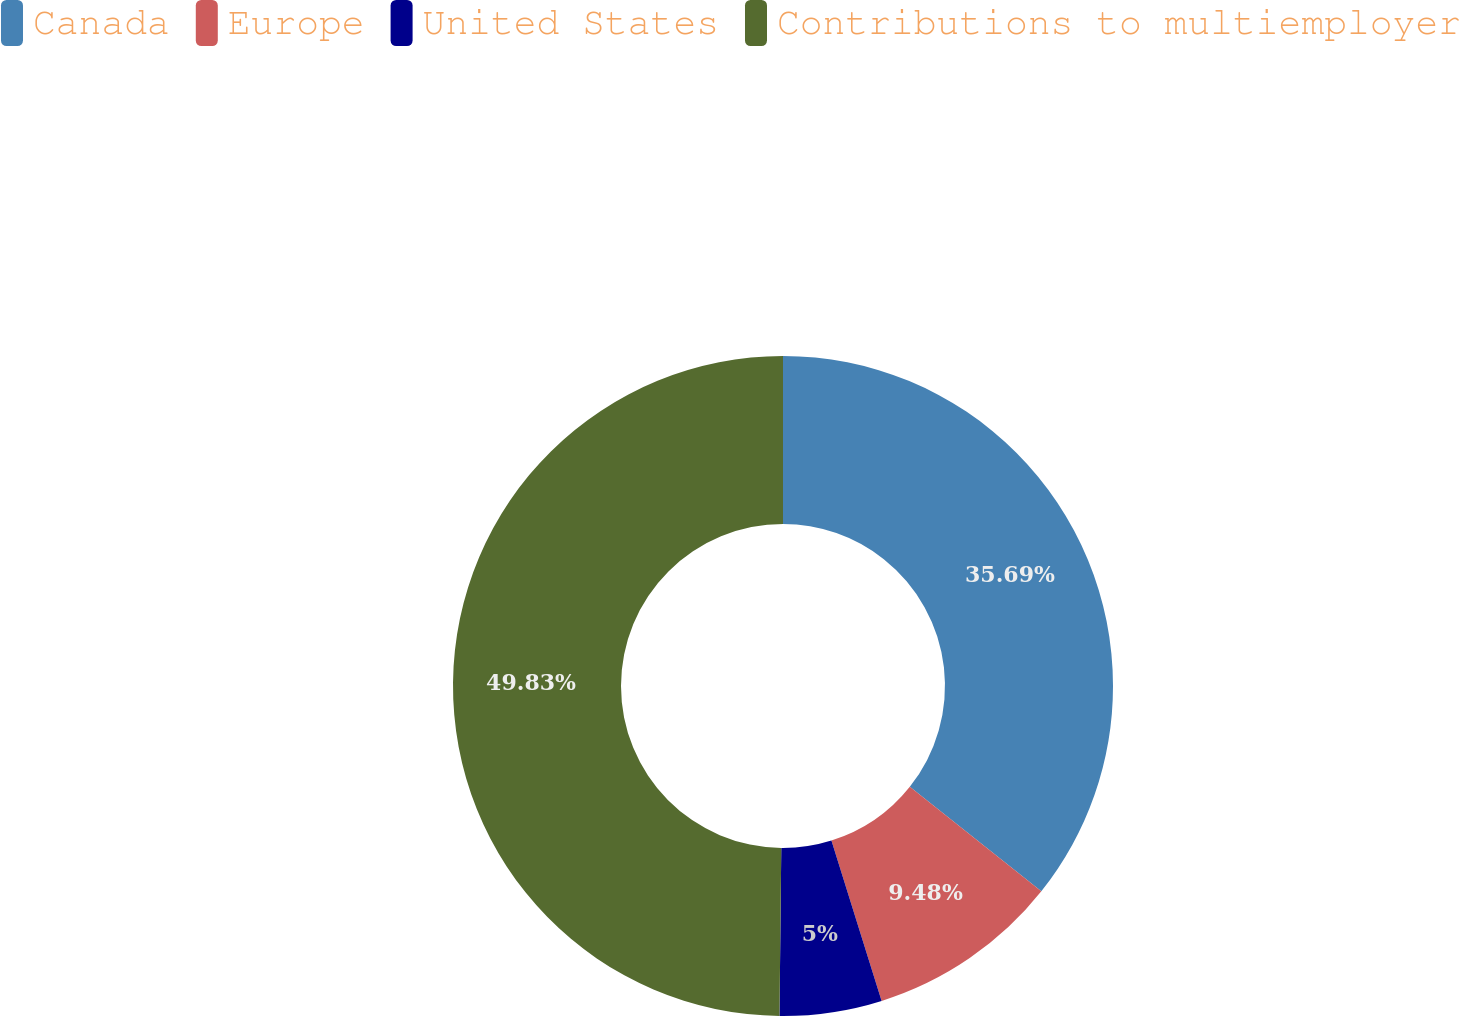Convert chart. <chart><loc_0><loc_0><loc_500><loc_500><pie_chart><fcel>Canada<fcel>Europe<fcel>United States<fcel>Contributions to multiemployer<nl><fcel>35.69%<fcel>9.48%<fcel>5.0%<fcel>49.83%<nl></chart> 